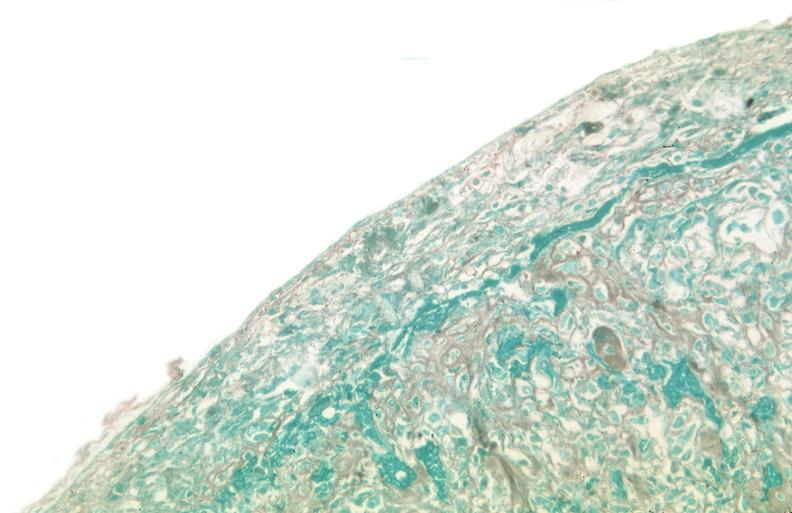what was used to sclerose emphysematous lung, alpha-1 antitrypsin deficiency?
Answer the question using a single word or phrase. Talc 